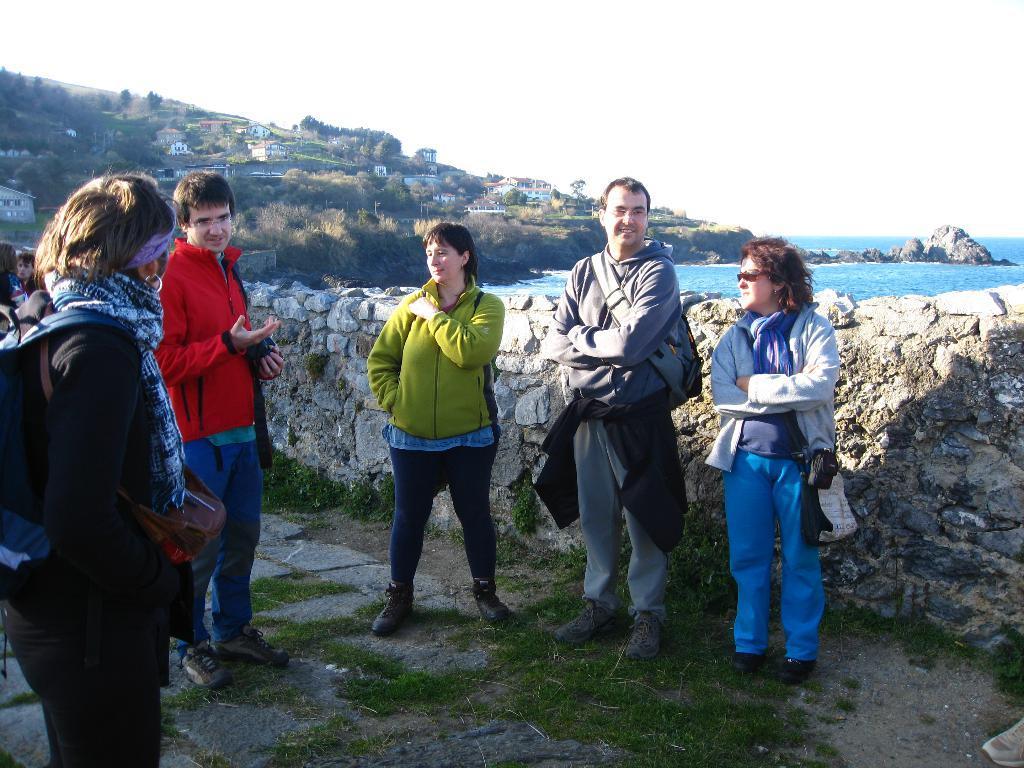In one or two sentences, can you explain what this image depicts? In this image there are a few people standing, behind them there is a wall and in the background there are buildings, trees, river and the sky. 